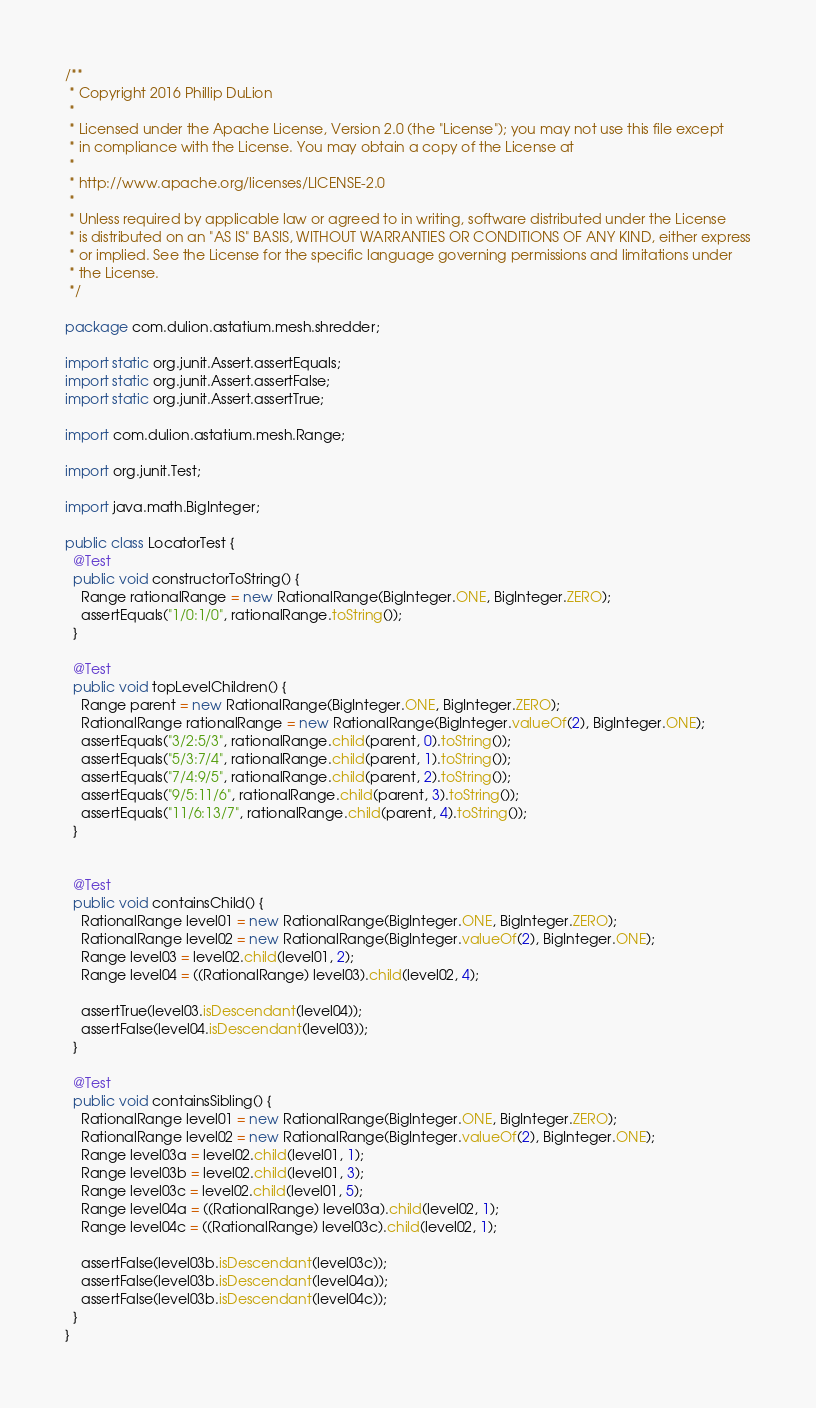<code> <loc_0><loc_0><loc_500><loc_500><_Java_>/**
 * Copyright 2016 Phillip DuLion
 *
 * Licensed under the Apache License, Version 2.0 (the "License"); you may not use this file except
 * in compliance with the License. You may obtain a copy of the License at
 *
 * http://www.apache.org/licenses/LICENSE-2.0
 *
 * Unless required by applicable law or agreed to in writing, software distributed under the License
 * is distributed on an "AS IS" BASIS, WITHOUT WARRANTIES OR CONDITIONS OF ANY KIND, either express
 * or implied. See the License for the specific language governing permissions and limitations under
 * the License.
 */

package com.dulion.astatium.mesh.shredder;

import static org.junit.Assert.assertEquals;
import static org.junit.Assert.assertFalse;
import static org.junit.Assert.assertTrue;

import com.dulion.astatium.mesh.Range;

import org.junit.Test;

import java.math.BigInteger;

public class LocatorTest {
  @Test
  public void constructorToString() {
    Range rationalRange = new RationalRange(BigInteger.ONE, BigInteger.ZERO);
    assertEquals("1/0:1/0", rationalRange.toString());
  }

  @Test
  public void topLevelChildren() {
    Range parent = new RationalRange(BigInteger.ONE, BigInteger.ZERO);
    RationalRange rationalRange = new RationalRange(BigInteger.valueOf(2), BigInteger.ONE);
    assertEquals("3/2:5/3", rationalRange.child(parent, 0).toString());
    assertEquals("5/3:7/4", rationalRange.child(parent, 1).toString());
    assertEquals("7/4:9/5", rationalRange.child(parent, 2).toString());
    assertEquals("9/5:11/6", rationalRange.child(parent, 3).toString());
    assertEquals("11/6:13/7", rationalRange.child(parent, 4).toString());
  }


  @Test
  public void containsChild() {
    RationalRange level01 = new RationalRange(BigInteger.ONE, BigInteger.ZERO);
    RationalRange level02 = new RationalRange(BigInteger.valueOf(2), BigInteger.ONE);
    Range level03 = level02.child(level01, 2);
    Range level04 = ((RationalRange) level03).child(level02, 4);

    assertTrue(level03.isDescendant(level04));
    assertFalse(level04.isDescendant(level03));
  }

  @Test
  public void containsSibling() {
    RationalRange level01 = new RationalRange(BigInteger.ONE, BigInteger.ZERO);
    RationalRange level02 = new RationalRange(BigInteger.valueOf(2), BigInteger.ONE);
    Range level03a = level02.child(level01, 1);
    Range level03b = level02.child(level01, 3);
    Range level03c = level02.child(level01, 5);
    Range level04a = ((RationalRange) level03a).child(level02, 1);
    Range level04c = ((RationalRange) level03c).child(level02, 1);

    assertFalse(level03b.isDescendant(level03c));
    assertFalse(level03b.isDescendant(level04a));
    assertFalse(level03b.isDescendant(level04c));
  }
}
</code> 